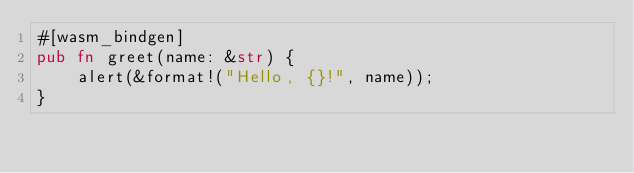Convert code to text. <code><loc_0><loc_0><loc_500><loc_500><_Rust_>#[wasm_bindgen]
pub fn greet(name: &str) {
    alert(&format!("Hello, {}!", name));
}
</code> 